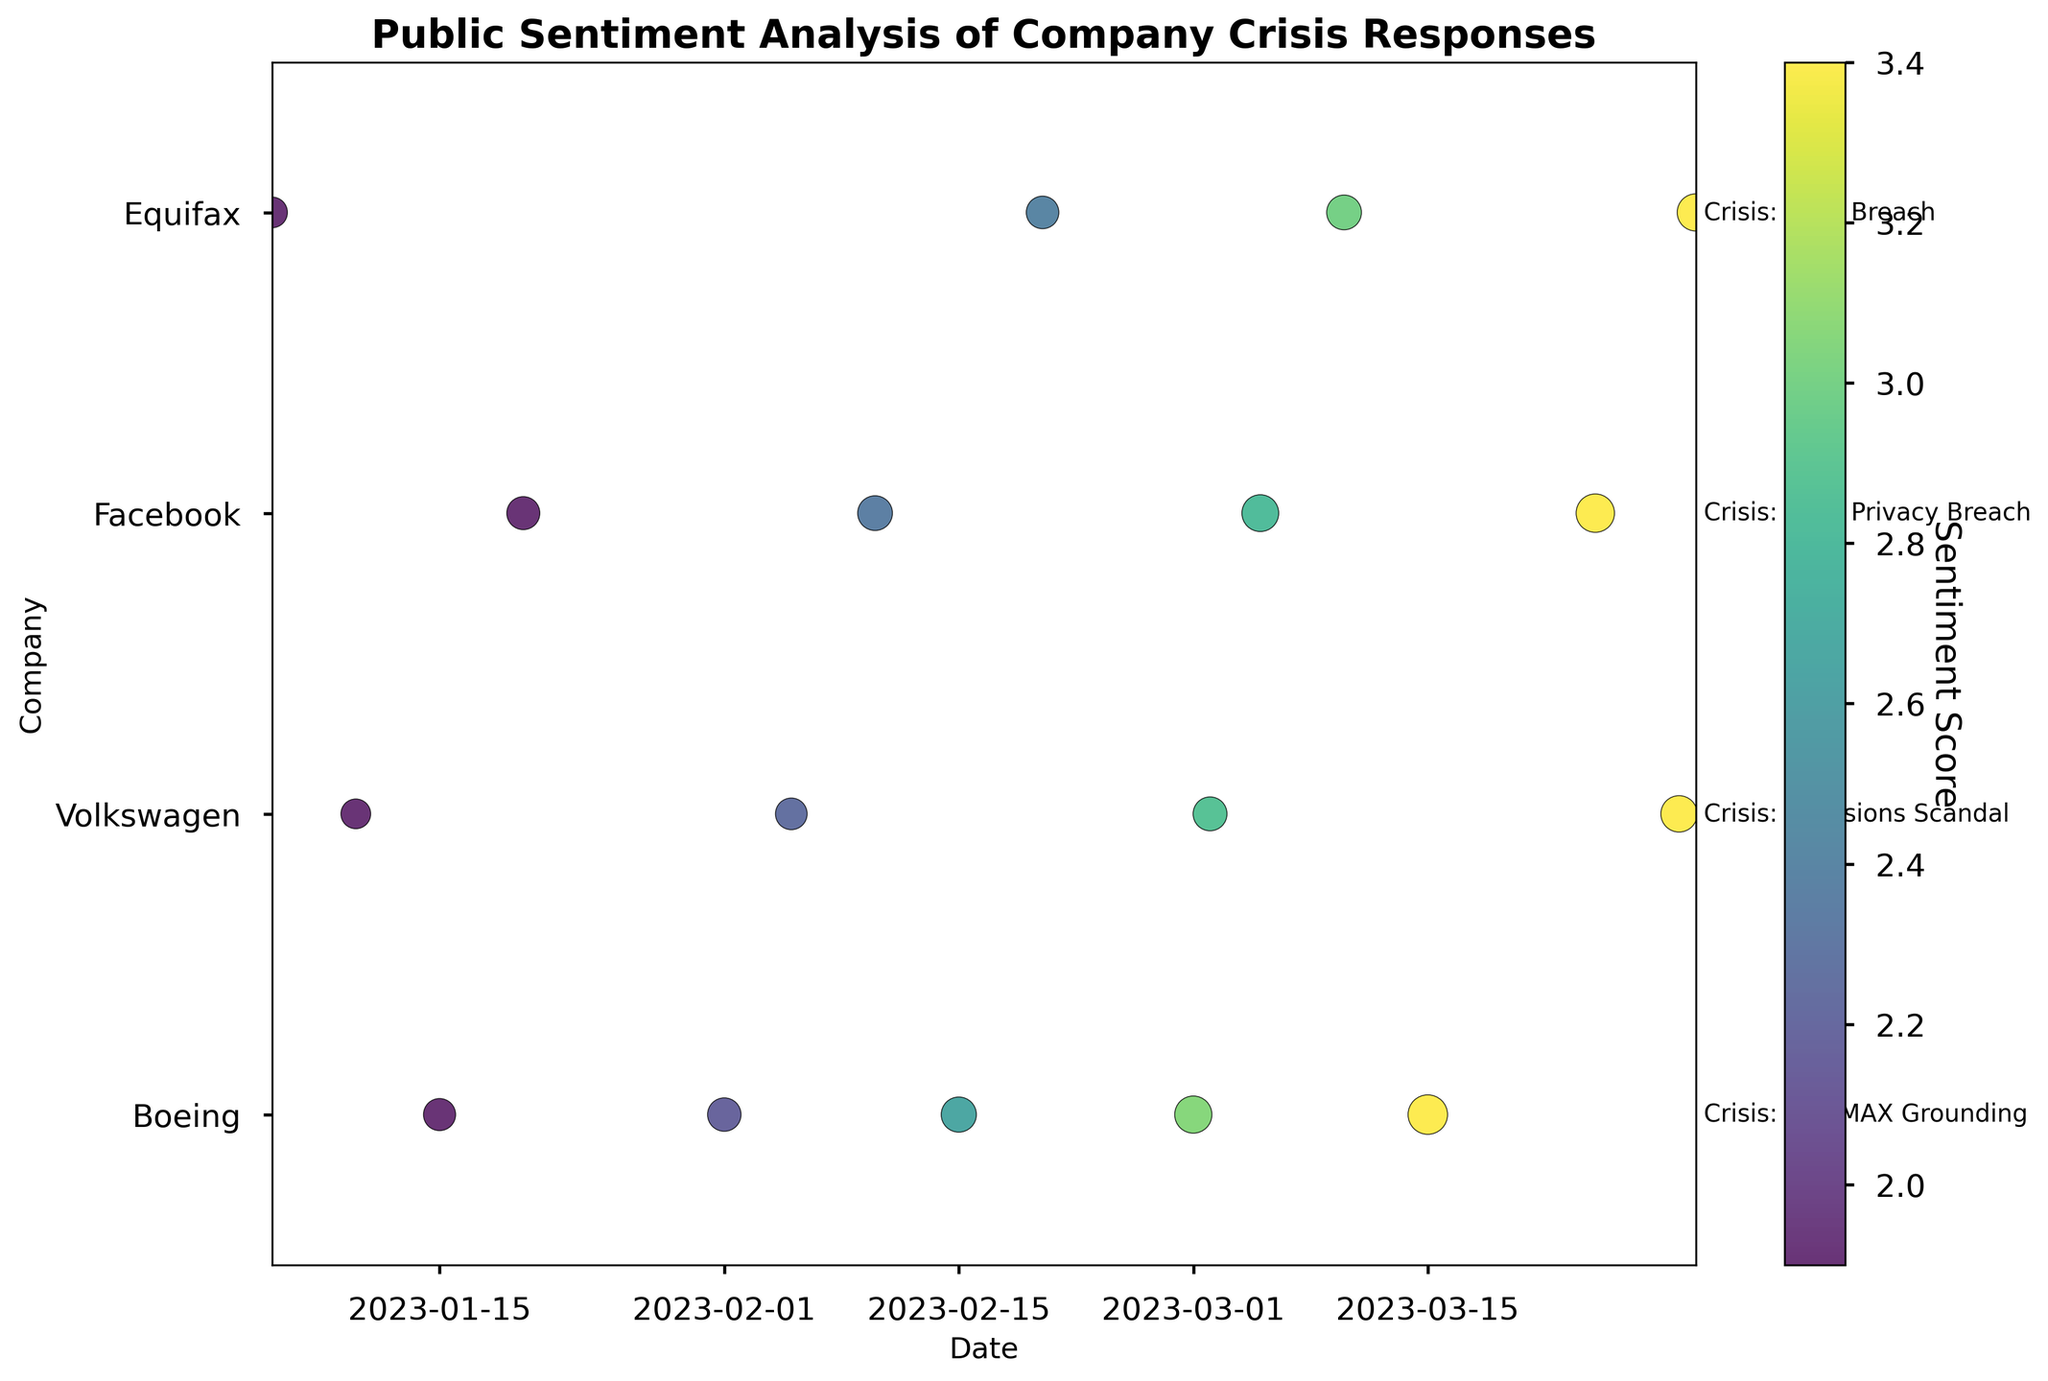what is the title of the plot? The title of the plot is shown at the top of the figure in bold text. It reads "Public Sentiment Analysis of Company Crisis Responses".
Answer: Public Sentiment Analysis of Company Crisis Responses Which company has the highest public trust index at the end of the time range? The x-axis represents the date, and the highest data point for Public Trust Index at the end of the range would indicate the company. Visualize the highest circle size to determine the company.
Answer: Facebook What is the colorbar in the plot used to indicate? The colorbar on the right side of the plot provides a gradient of colors representing different Sentiment Scores.
Answer: Sentiment Score How many companies are represented in the plot? Count the number of distinct companies listed on the y-axis. There are four companies: Boeing, Volkswagen, Facebook, and Equifax.
Answer: 4 Which company responded to the crisis with the most increase in public trust over time? To determine this, compare the relative size of circles (Public Trust Index) at the start and end of the time range for each company. Boeing shows the most significant increase from 35 to 53.
Answer: Boeing What crisis is associated with Equifax in the plot? Look at the y-axis label associated with Equifax and the descriptive text next to the company's last data point. It mentions the crisis as "Data Breach."
Answer: Data Breach Whose public sentiment score improved the least throughout the timeline? Comparing the initial and final sentiment scores, Volkswagen's sentiment score increased from 1.8 to 3.5, which is the lowest total increase among the companies.
Answer: Volkswagen Which company has the darkest colored points at any time? The color represents the Sentiment Score, and the darkest color in the viridis colormap corresponds to the lowest score. Therefore, Volkswagen with the point at 1.8 has the darkest colors.
Answer: Volkswagen How does the public trust index of Facebook change over time? Look at the size of the circles associated with Facebook on the y-axis. The Public Trust Index increases from 37 to 50 over the plotted dates.
Answer: Increases from 37 to 50 Which company had a crisis responded to earliest in the year? Check the earliest date represented on the x-axis for each company's data. Equifax has data starting on January 5th.
Answer: Equifax 